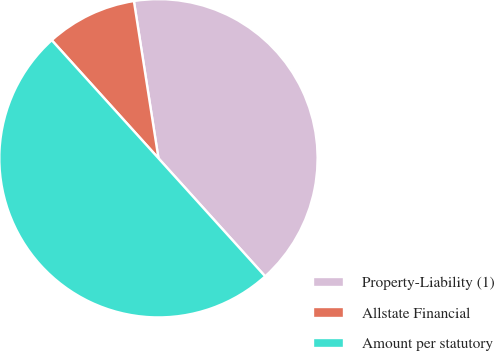Convert chart to OTSL. <chart><loc_0><loc_0><loc_500><loc_500><pie_chart><fcel>Property-Liability (1)<fcel>Allstate Financial<fcel>Amount per statutory<nl><fcel>40.77%<fcel>9.23%<fcel>50.0%<nl></chart> 